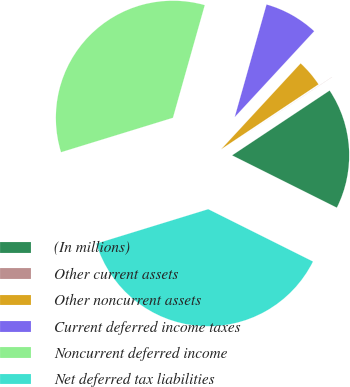Convert chart to OTSL. <chart><loc_0><loc_0><loc_500><loc_500><pie_chart><fcel>(In millions)<fcel>Other current assets<fcel>Other noncurrent assets<fcel>Current deferred income taxes<fcel>Noncurrent deferred income<fcel>Net deferred tax liabilities<nl><fcel>16.71%<fcel>0.02%<fcel>3.76%<fcel>7.5%<fcel>34.13%<fcel>37.87%<nl></chart> 